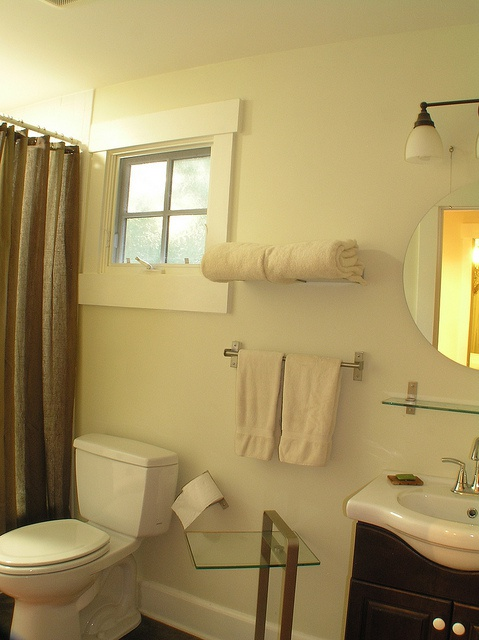Describe the objects in this image and their specific colors. I can see toilet in khaki, tan, and olive tones and sink in khaki, tan, and olive tones in this image. 